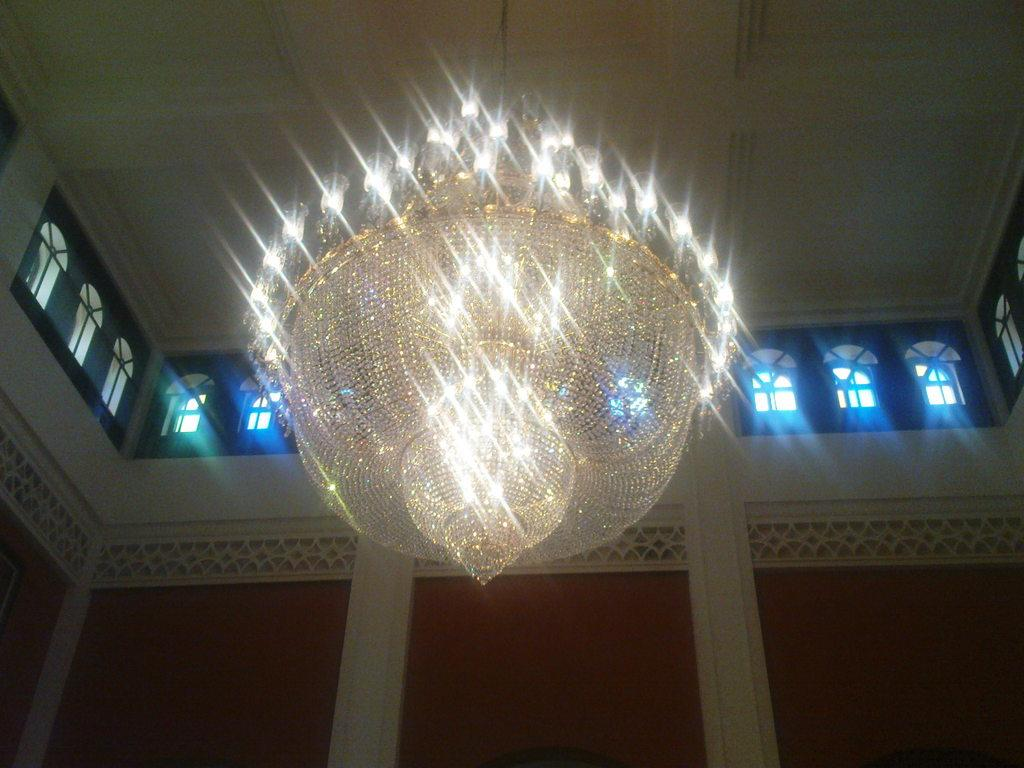Where was the image taken? The image was taken inside a building. What can be seen in the middle of the image? There are lights and windows in the middle of the image. What color is the vein visible in the image? There is no vein visible in the image. What note is being played by the instrument in the image? There is no instrument or note present in the image. 